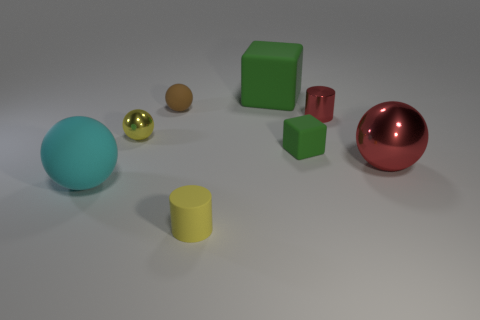Does the cylinder in front of the large red thing have the same color as the tiny shiny ball that is in front of the small red metal cylinder?
Offer a very short reply. Yes. Are there any other things of the same color as the large rubber block?
Provide a succinct answer. Yes. Do the cyan rubber ball and the red ball have the same size?
Give a very brief answer. Yes. Are there any yellow metallic objects right of the big cyan object?
Keep it short and to the point. Yes. There is a rubber thing that is both behind the yellow shiny ball and on the right side of the small brown sphere; what is its size?
Make the answer very short. Large. What number of things are big red matte things or brown objects?
Provide a short and direct response. 1. There is a brown rubber ball; is it the same size as the cylinder that is in front of the large rubber ball?
Provide a succinct answer. Yes. What is the size of the rubber ball in front of the red metal object that is on the left side of the red metal object that is in front of the small green rubber cube?
Offer a very short reply. Large. Are any large yellow cubes visible?
Make the answer very short. No. There is a large sphere that is the same color as the small metal cylinder; what material is it?
Ensure brevity in your answer.  Metal. 